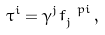Convert formula to latex. <formula><loc_0><loc_0><loc_500><loc_500>\tau ^ { i } = \gamma ^ { j } f _ { j } ^ { \ p i } \, ,</formula> 